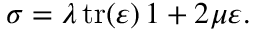<formula> <loc_0><loc_0><loc_500><loc_500>\sigma = \lambda \, t r ( \varepsilon ) \, 1 + 2 \mu \varepsilon .</formula> 